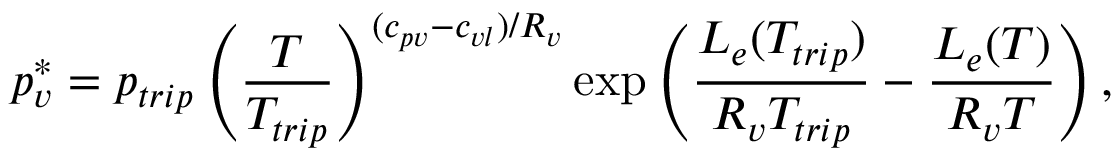Convert formula to latex. <formula><loc_0><loc_0><loc_500><loc_500>p _ { v } ^ { * } = p _ { t r i p } \left ( \frac { T } { T _ { t r i p } } \right ) ^ { ( c _ { p v } - c _ { v l } ) / R _ { v } } \exp \left ( \frac { L _ { e } ( T _ { t r i p } ) } { R _ { v } T _ { t r i p } } - \frac { L _ { e } ( T ) } { R _ { v } T } \right ) ,</formula> 